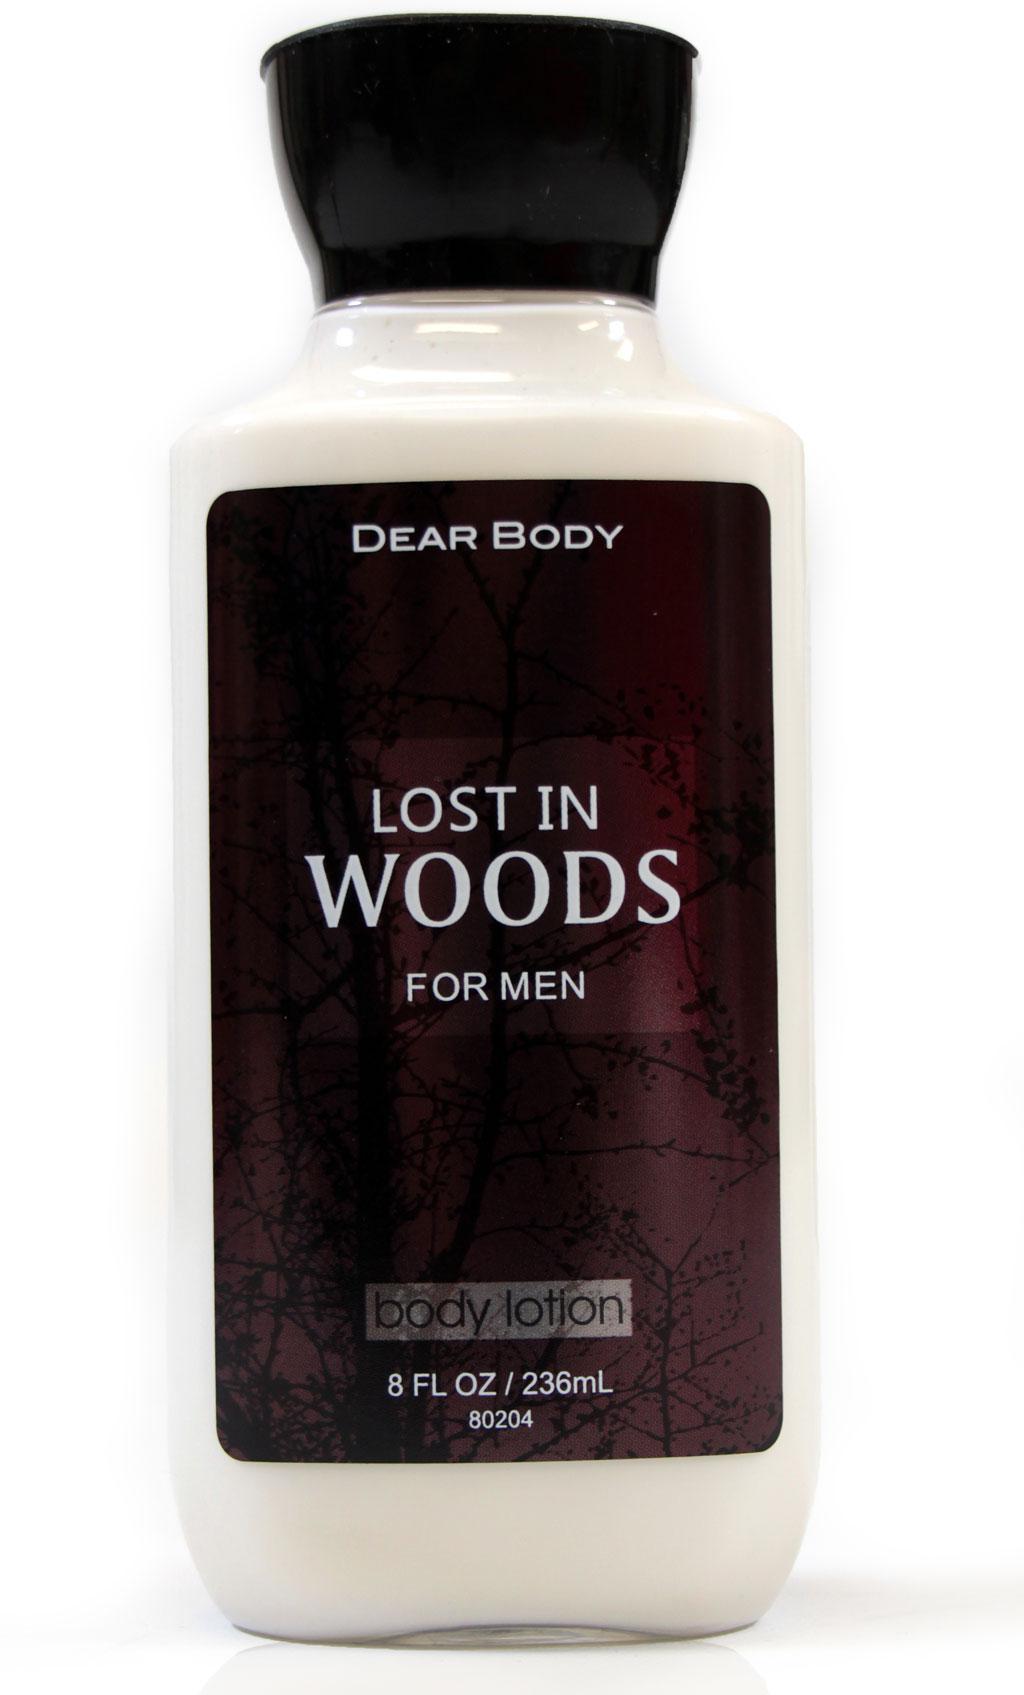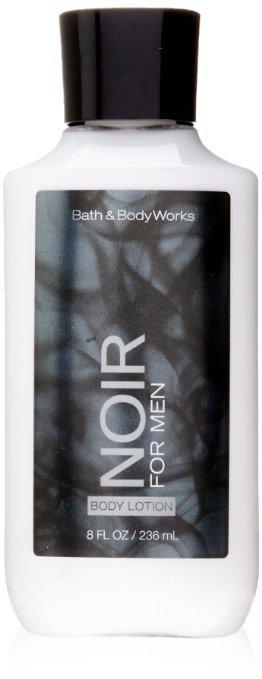The first image is the image on the left, the second image is the image on the right. For the images displayed, is the sentence "There are two bottles, both with black caps and white content." factually correct? Answer yes or no. Yes. The first image is the image on the left, the second image is the image on the right. Given the left and right images, does the statement "An image features one product that stands on its black cap." hold true? Answer yes or no. No. 